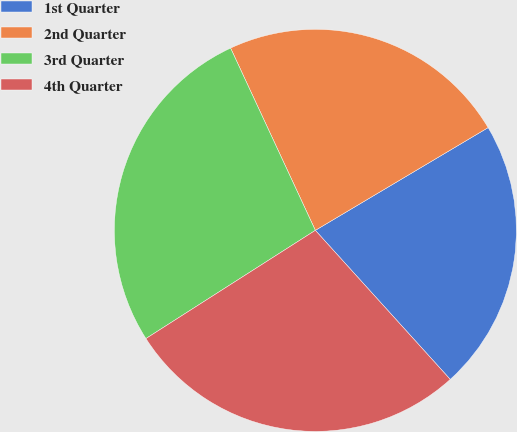Convert chart to OTSL. <chart><loc_0><loc_0><loc_500><loc_500><pie_chart><fcel>1st Quarter<fcel>2nd Quarter<fcel>3rd Quarter<fcel>4th Quarter<nl><fcel>21.83%<fcel>23.39%<fcel>27.12%<fcel>27.66%<nl></chart> 